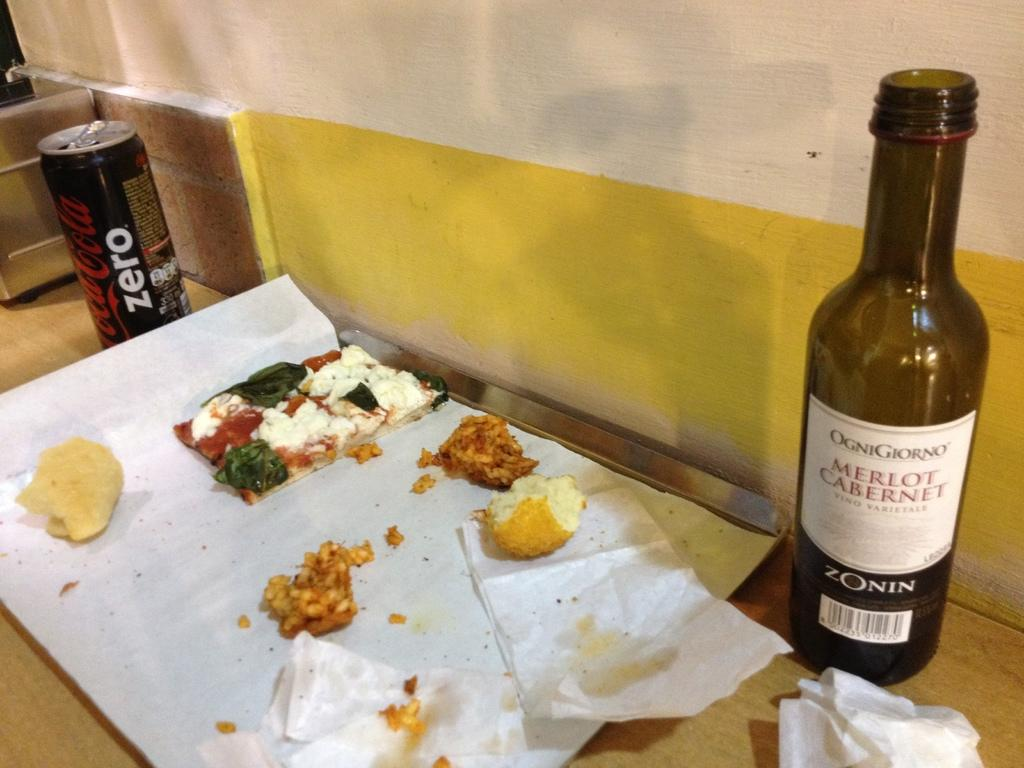<image>
Summarize the visual content of the image. A bottle of Merlot Cabernet is next to the remnants of a meal. 